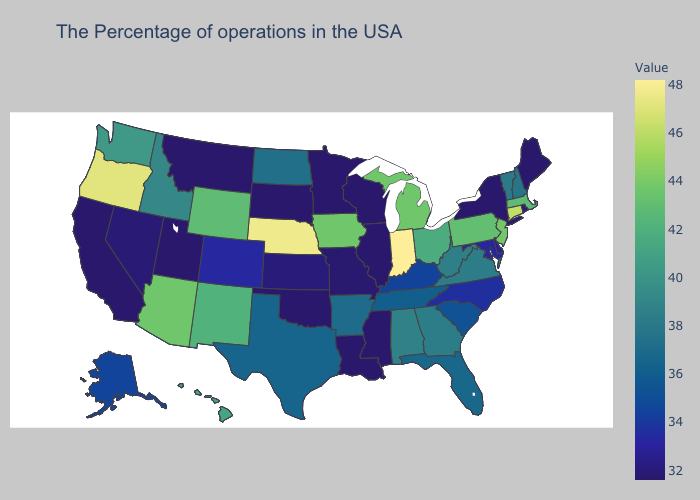Does Hawaii have the lowest value in the USA?
Be succinct. No. Does Oregon have the highest value in the West?
Answer briefly. Yes. Which states hav the highest value in the Northeast?
Keep it brief. Connecticut. Does Oregon have the highest value in the West?
Be succinct. Yes. Does Vermont have a lower value than Massachusetts?
Answer briefly. Yes. Among the states that border Montana , which have the lowest value?
Concise answer only. South Dakota. Among the states that border South Carolina , which have the highest value?
Concise answer only. Georgia. 